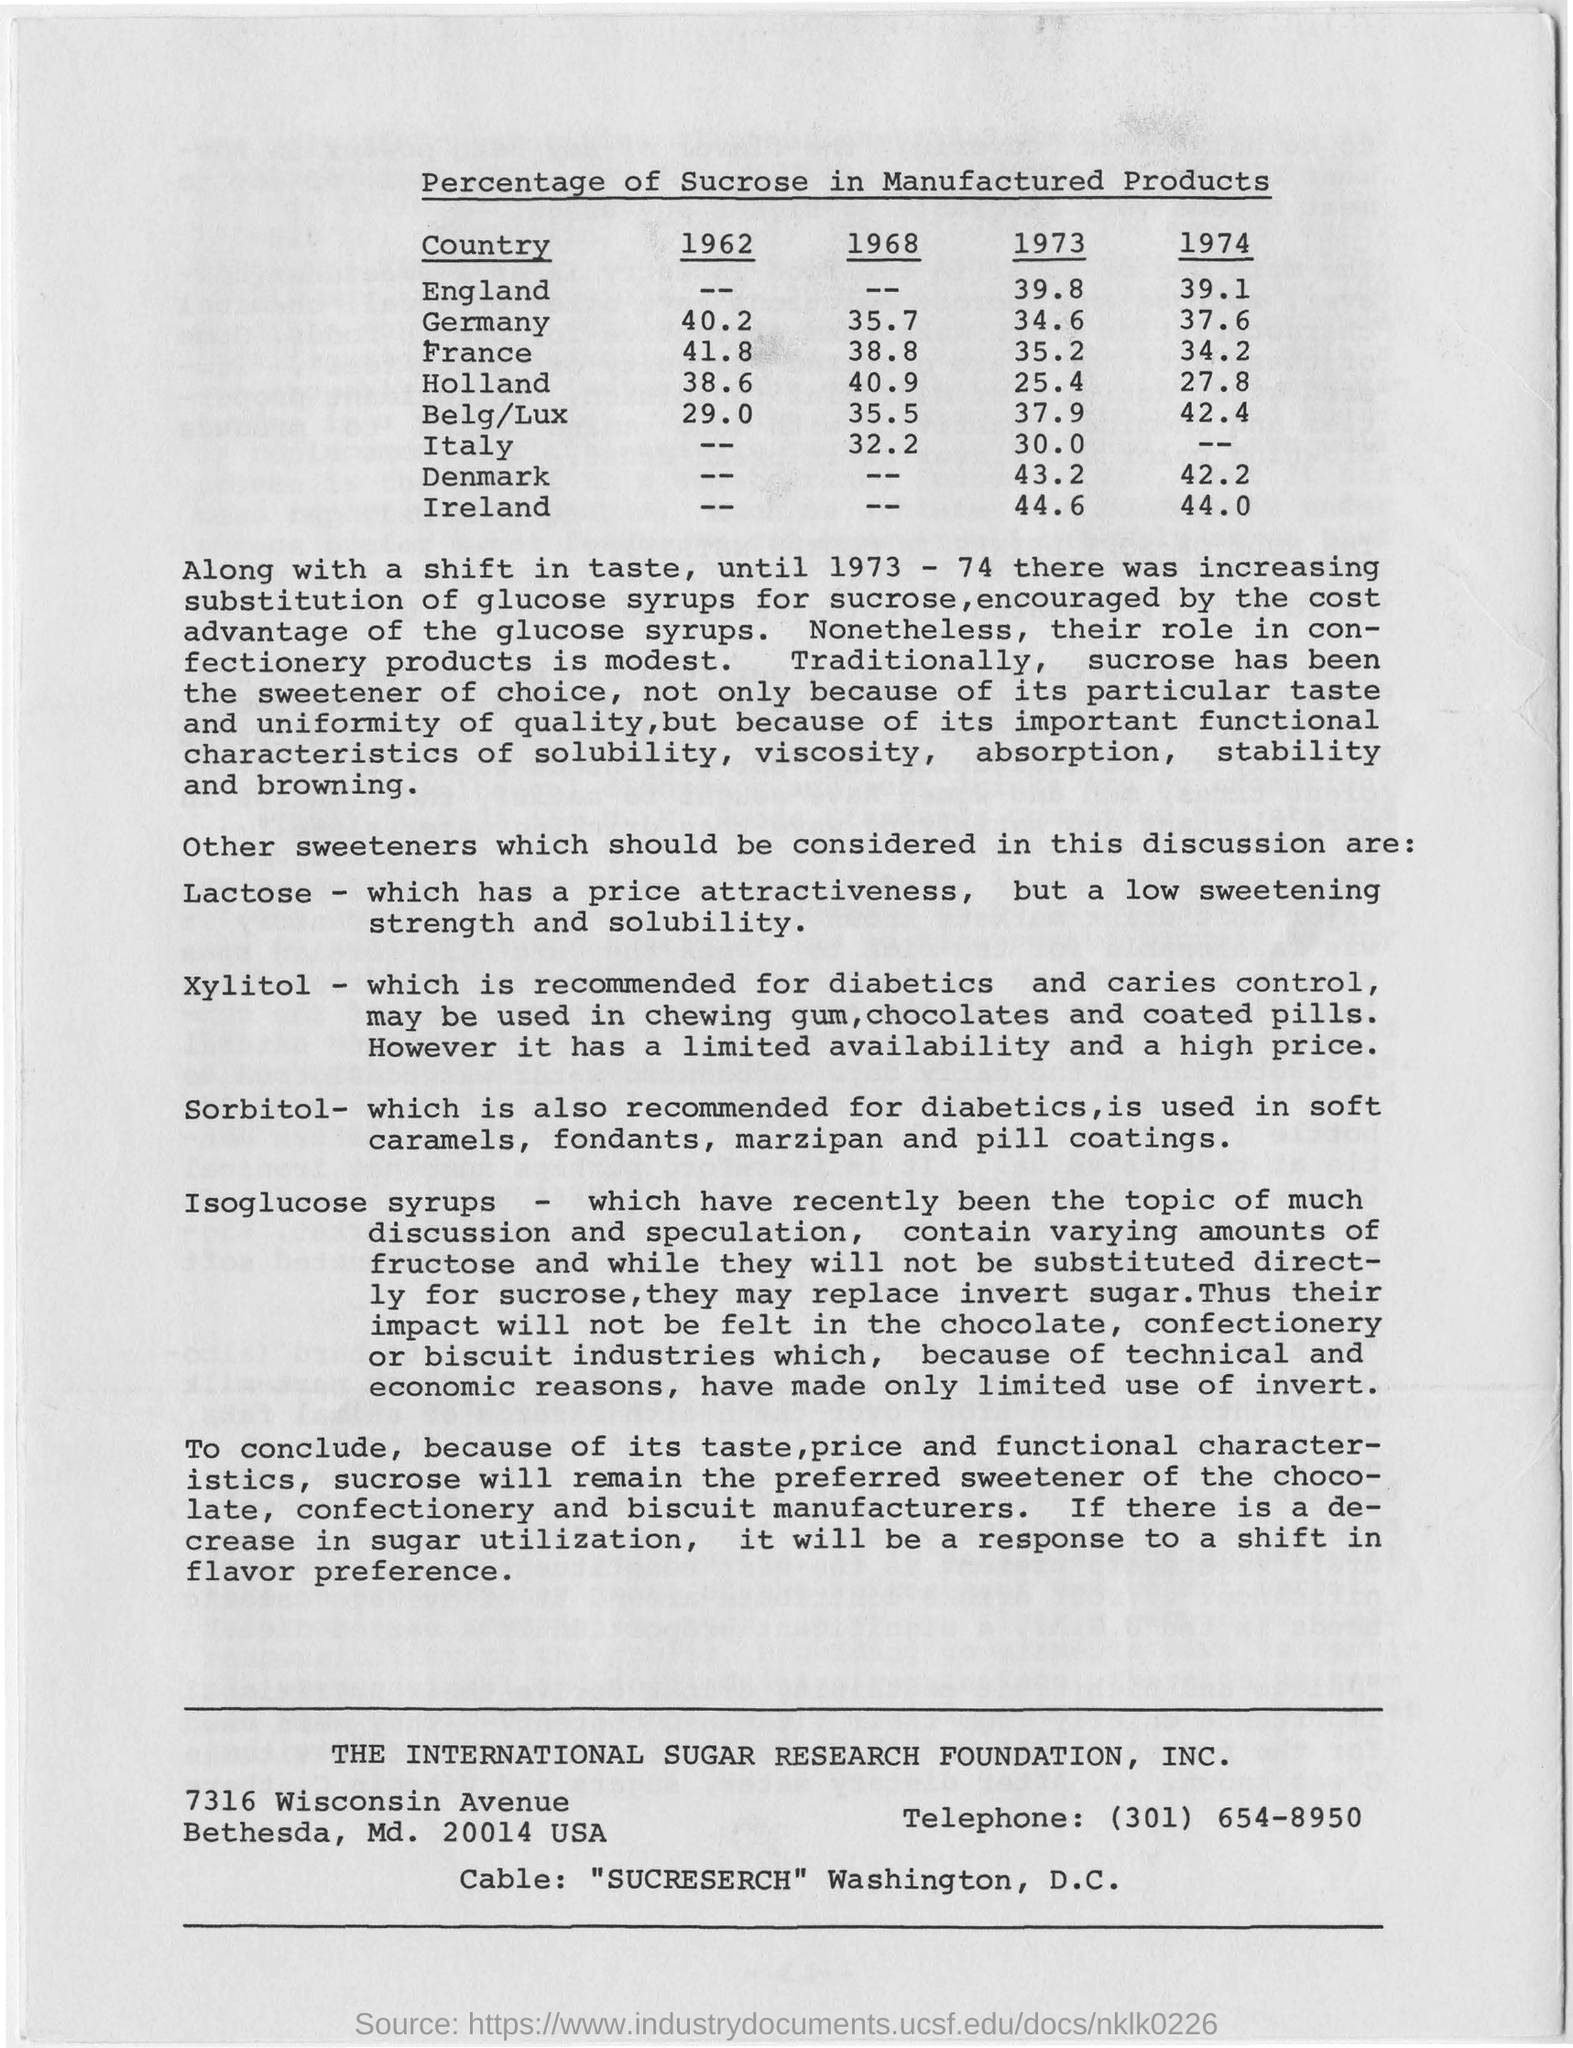Highlight a few significant elements in this photo. In 1973, the percentage of sucrose in manufactured products in Italy was approximately 30%. In 1973, the percentage of sucrose in manufactured products in England was 39.8%. Until the year 1973-74, there was an increasing substitution of glucose syrups for sucrose. In 1962, the percentage of sucrose in manufactured products in Germany was 40.2%. 